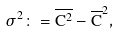<formula> <loc_0><loc_0><loc_500><loc_500>\sigma ^ { 2 } \colon = \overline { C ^ { 2 } } - \overline { C } ^ { 2 } ,</formula> 